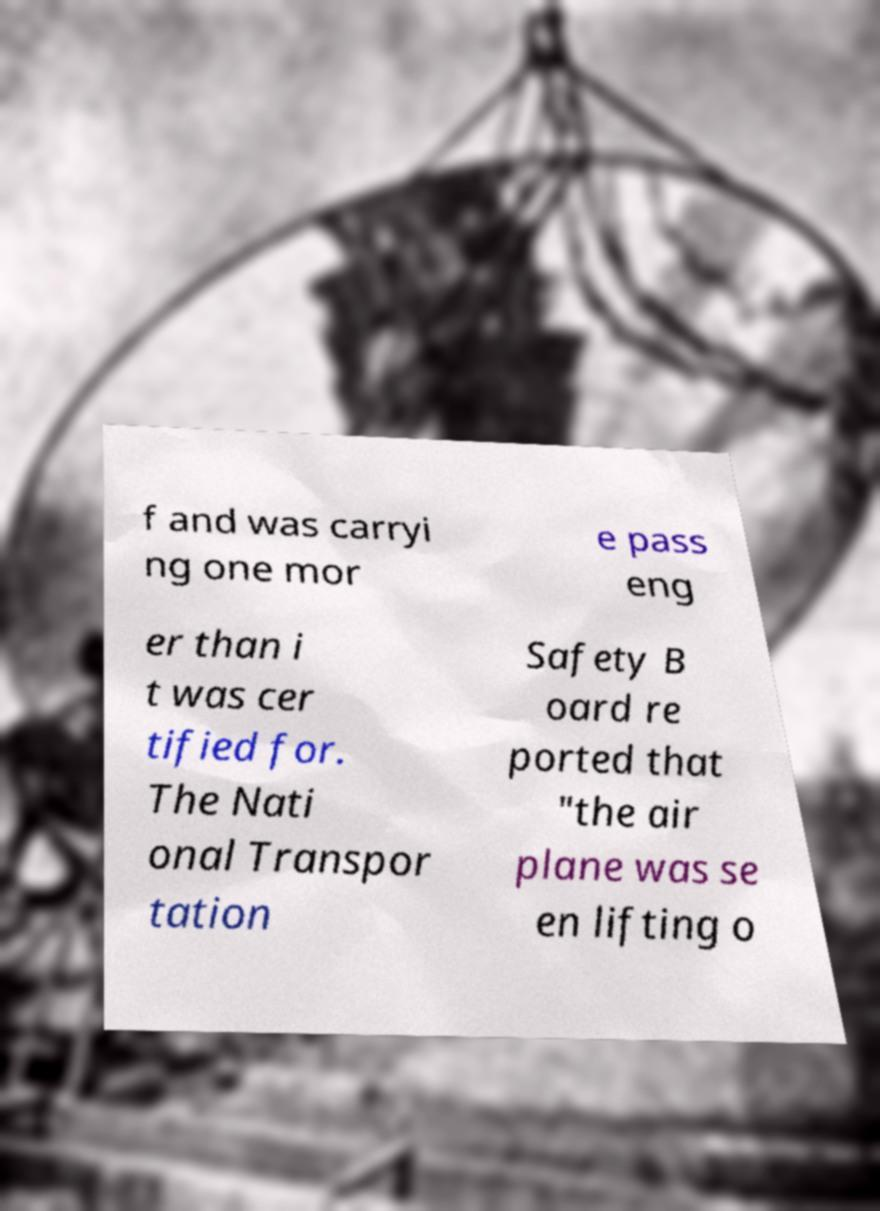Can you accurately transcribe the text from the provided image for me? f and was carryi ng one mor e pass eng er than i t was cer tified for. The Nati onal Transpor tation Safety B oard re ported that "the air plane was se en lifting o 